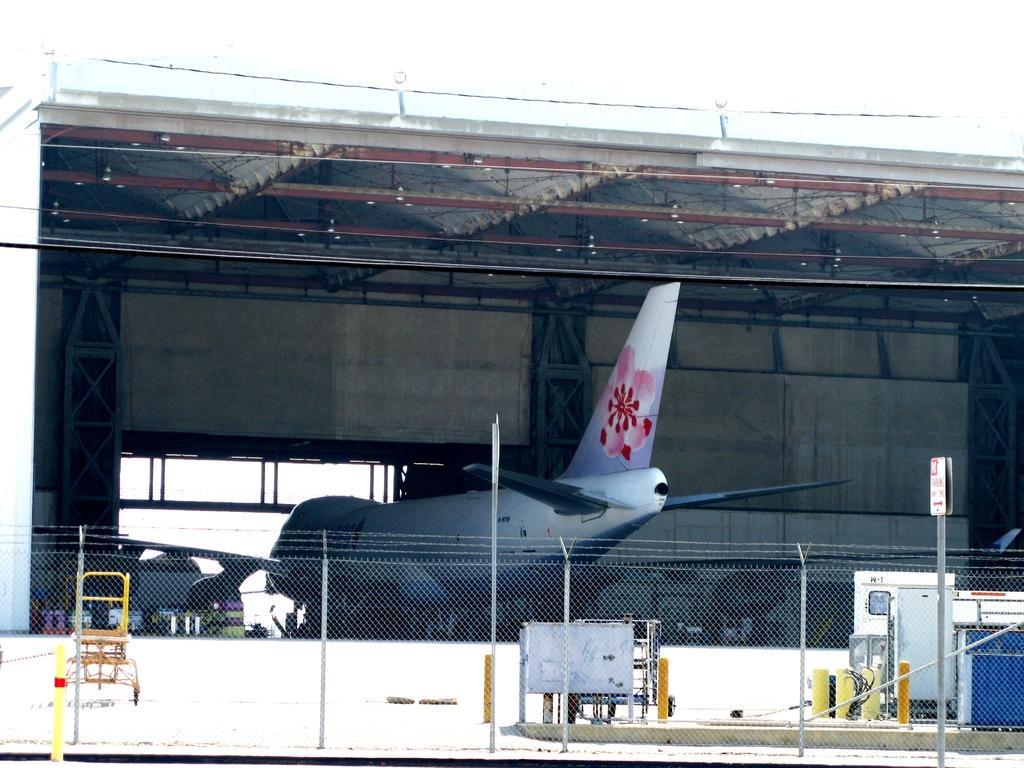How would you summarize this image in a sentence or two? There is an aeroplane. Here we can see a fence, poles, board, and a shed. In the background there is sky. 